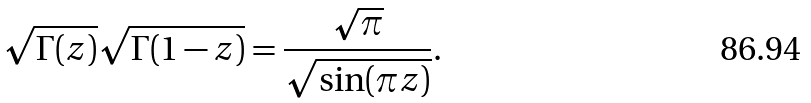Convert formula to latex. <formula><loc_0><loc_0><loc_500><loc_500>\sqrt { \Gamma ( z ) } \sqrt { \Gamma ( 1 - z ) } = { \frac { \sqrt { \pi } } { \sqrt { \sin ( \pi z ) } } } .</formula> 